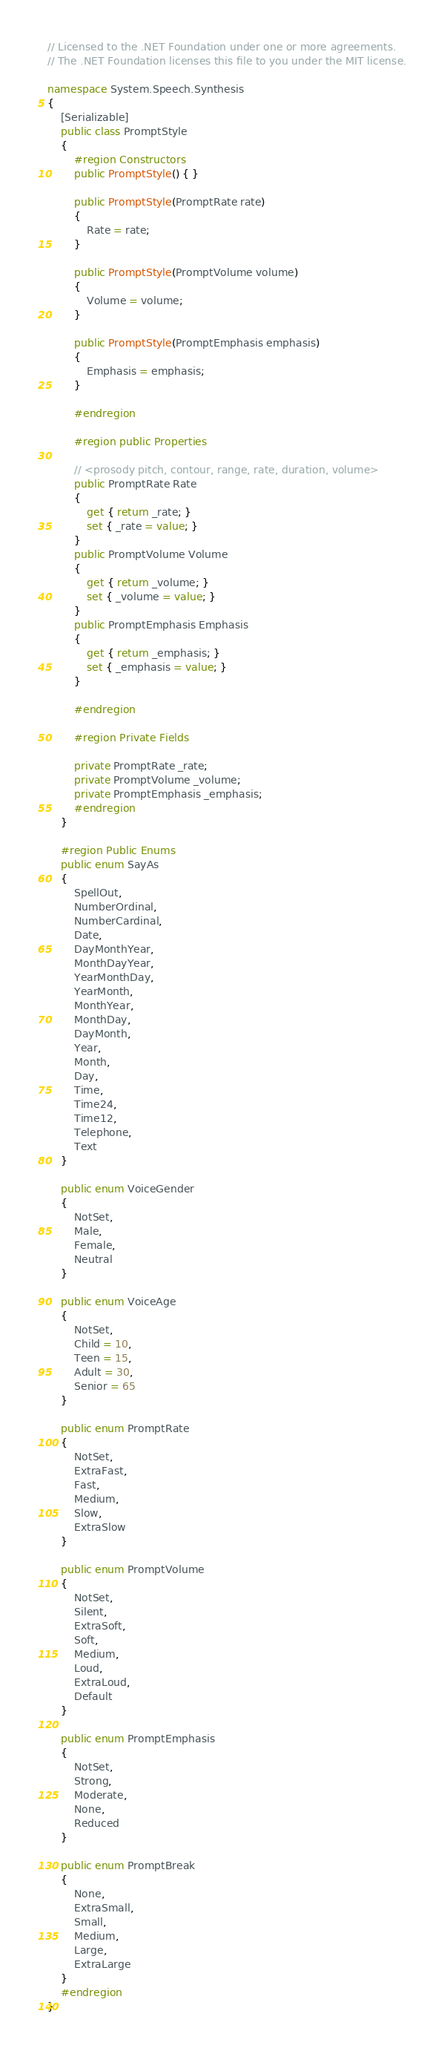<code> <loc_0><loc_0><loc_500><loc_500><_C#_>// Licensed to the .NET Foundation under one or more agreements.
// The .NET Foundation licenses this file to you under the MIT license.

namespace System.Speech.Synthesis
{
    [Serializable]
    public class PromptStyle
    {
        #region Constructors
        public PromptStyle() { }

        public PromptStyle(PromptRate rate)
        {
            Rate = rate;
        }

        public PromptStyle(PromptVolume volume)
        {
            Volume = volume;
        }

        public PromptStyle(PromptEmphasis emphasis)
        {
            Emphasis = emphasis;
        }

        #endregion

        #region public Properties

        // <prosody pitch, contour, range, rate, duration, volume>
        public PromptRate Rate
        {
            get { return _rate; }
            set { _rate = value; }
        }
        public PromptVolume Volume
        {
            get { return _volume; }
            set { _volume = value; }
        }
        public PromptEmphasis Emphasis
        {
            get { return _emphasis; }
            set { _emphasis = value; }
        }

        #endregion

        #region Private Fields

        private PromptRate _rate;
        private PromptVolume _volume;
        private PromptEmphasis _emphasis;
        #endregion
    }

    #region Public Enums
    public enum SayAs
    {
        SpellOut,
        NumberOrdinal,
        NumberCardinal,
        Date,
        DayMonthYear,
        MonthDayYear,
        YearMonthDay,
        YearMonth,
        MonthYear,
        MonthDay,
        DayMonth,
        Year,
        Month,
        Day,
        Time,
        Time24,
        Time12,
        Telephone,
        Text
    }

    public enum VoiceGender
    {
        NotSet,
        Male,
        Female,
        Neutral
    }

    public enum VoiceAge
    {
        NotSet,
        Child = 10,
        Teen = 15,
        Adult = 30,
        Senior = 65
    }

    public enum PromptRate
    {
        NotSet,
        ExtraFast,
        Fast,
        Medium,
        Slow,
        ExtraSlow
    }

    public enum PromptVolume
    {
        NotSet,
        Silent,
        ExtraSoft,
        Soft,
        Medium,
        Loud,
        ExtraLoud,
        Default
    }

    public enum PromptEmphasis
    {
        NotSet,
        Strong,
        Moderate,
        None,
        Reduced
    }

    public enum PromptBreak
    {
        None,
        ExtraSmall,
        Small,
        Medium,
        Large,
        ExtraLarge
    }
    #endregion
}
</code> 